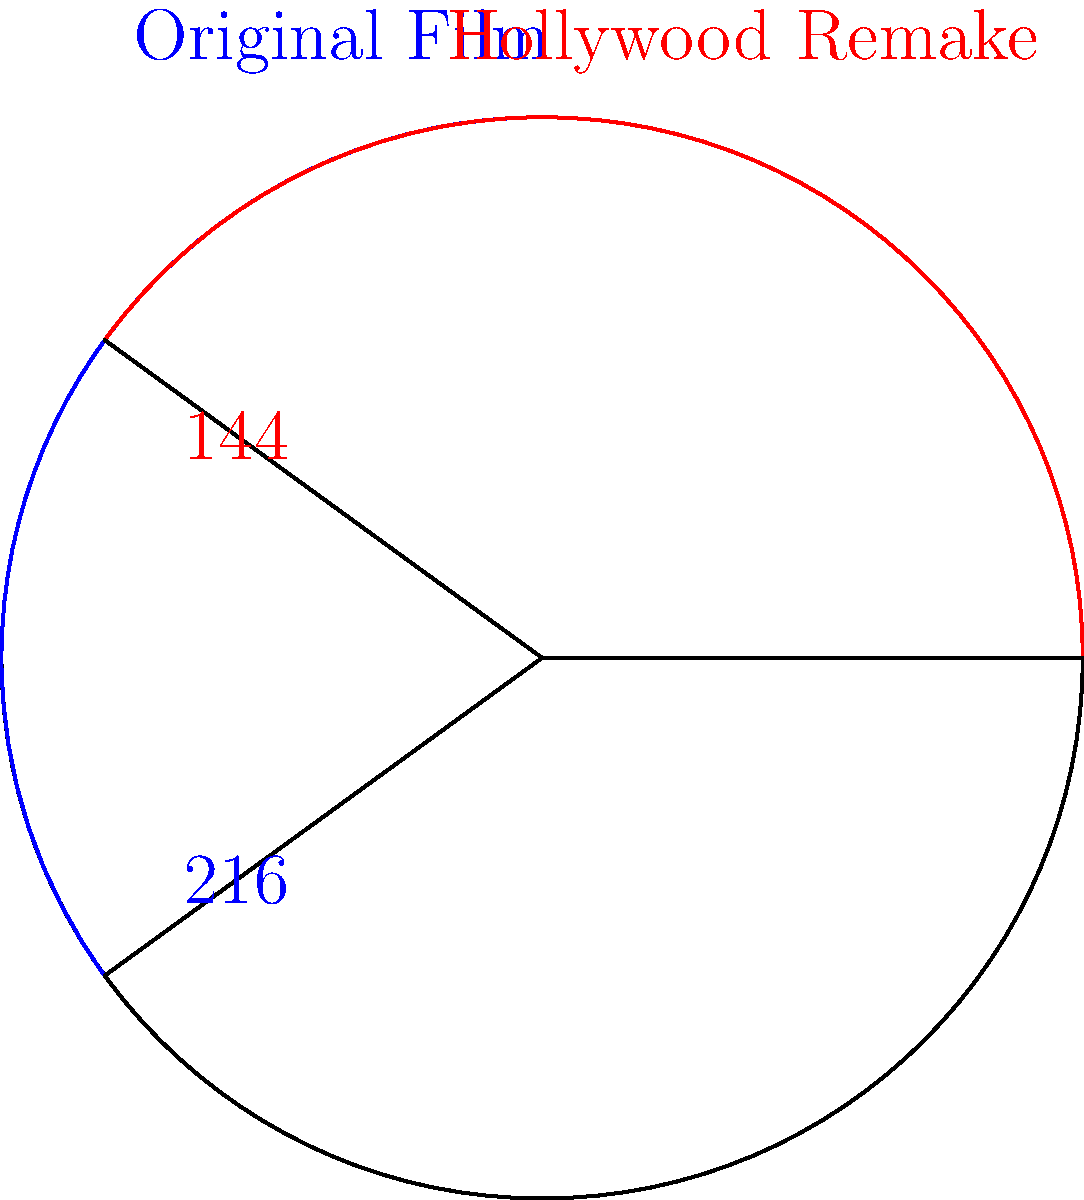A circular chart represents the market share of an acclaimed Vietnamese film and its Hollywood remake. The original film occupies a sector with a central angle of 216°, while the remake takes up 144°. If the total area of the chart is 314 square units, what is the difference in area between the sectors representing the original film and its remake? Let's approach this step-by-step:

1) The total area of the circle is 314 square units. We can use this to find the radius:
   $$A = \pi r^2$$
   $$314 = \pi r^2$$
   $$r^2 = \frac{314}{\pi} \approx 100$$
   $$r = 10$$

2) The formula for the area of a sector is:
   $$A_{sector} = \frac{\theta}{360°} \pi r^2$$
   Where $\theta$ is the central angle in degrees.

3) For the original film:
   $$A_{original} = \frac{216°}{360°} \pi (10)^2 = 0.6 \pi (100) = 60\pi$$

4) For the Hollywood remake:
   $$A_{remake} = \frac{144°}{360°} \pi (10)^2 = 0.4 \pi (100) = 40\pi$$

5) The difference in area is:
   $$A_{difference} = A_{original} - A_{remake} = 60\pi - 40\pi = 20\pi$$

6) Converting to square units:
   $$A_{difference} = 20\pi \approx 62.83$$ square units
Answer: 62.83 square units 